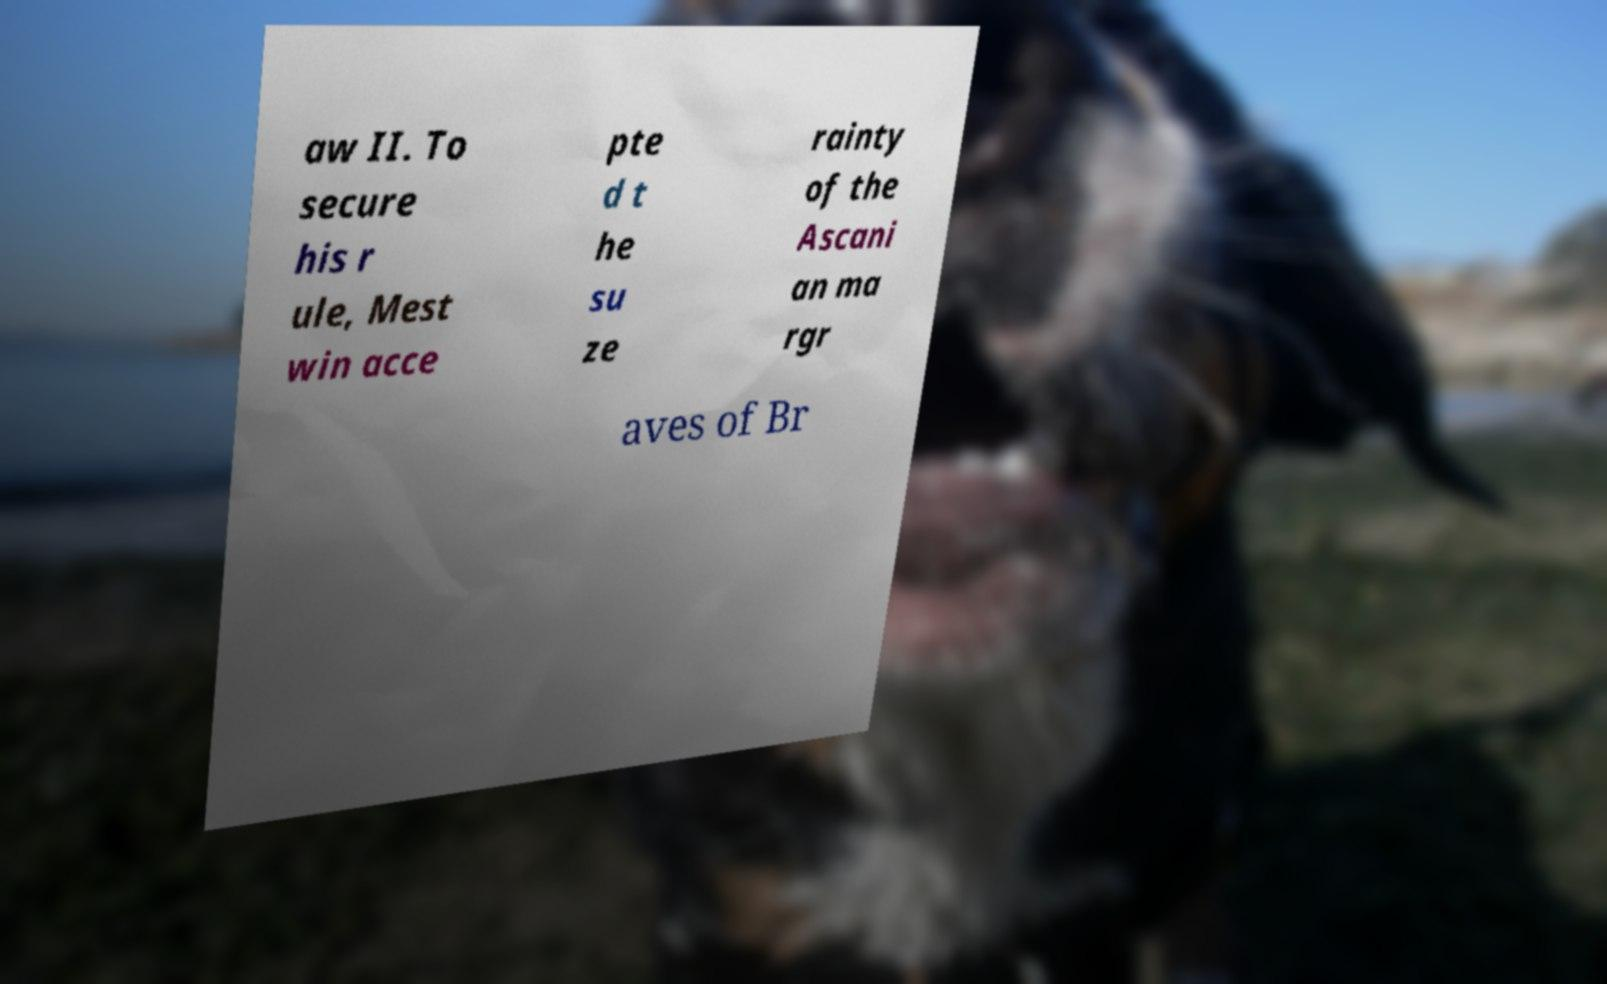Can you accurately transcribe the text from the provided image for me? aw II. To secure his r ule, Mest win acce pte d t he su ze rainty of the Ascani an ma rgr aves of Br 